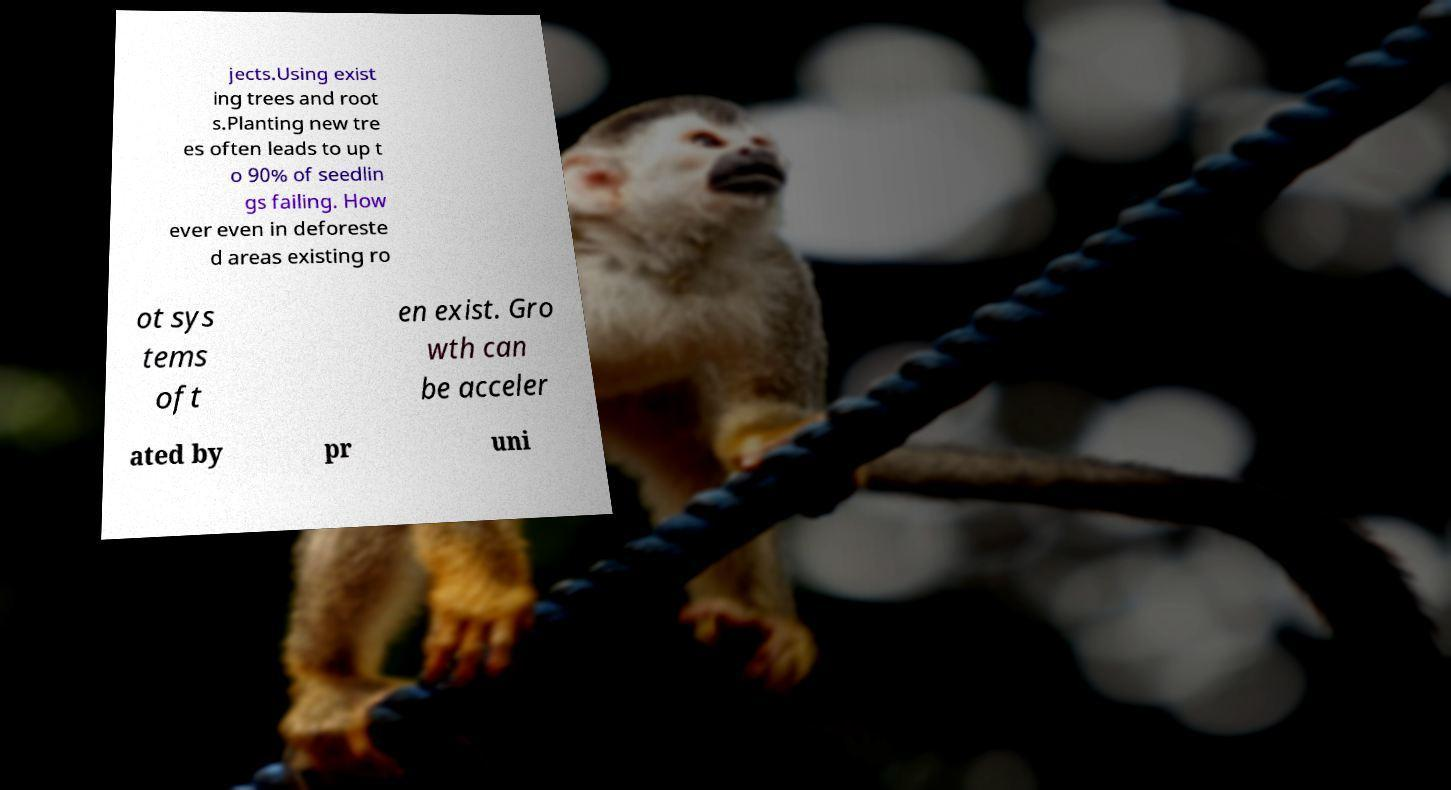Could you assist in decoding the text presented in this image and type it out clearly? jects.Using exist ing trees and root s.Planting new tre es often leads to up t o 90% of seedlin gs failing. How ever even in deforeste d areas existing ro ot sys tems oft en exist. Gro wth can be acceler ated by pr uni 